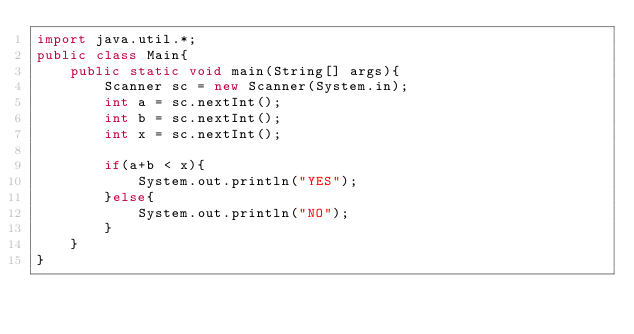<code> <loc_0><loc_0><loc_500><loc_500><_Java_>import java.util.*;
public class Main{
	public static void main(String[] args){
    	Scanner sc = new Scanner(System.in);
      	int a = sc.nextInt();
      	int b = sc.nextInt();
      	int x = sc.nextInt();
      
      	if(a+b < x){
        	System.out.println("YES");
        }else{
        	System.out.println("NO");
        }
    }
}</code> 